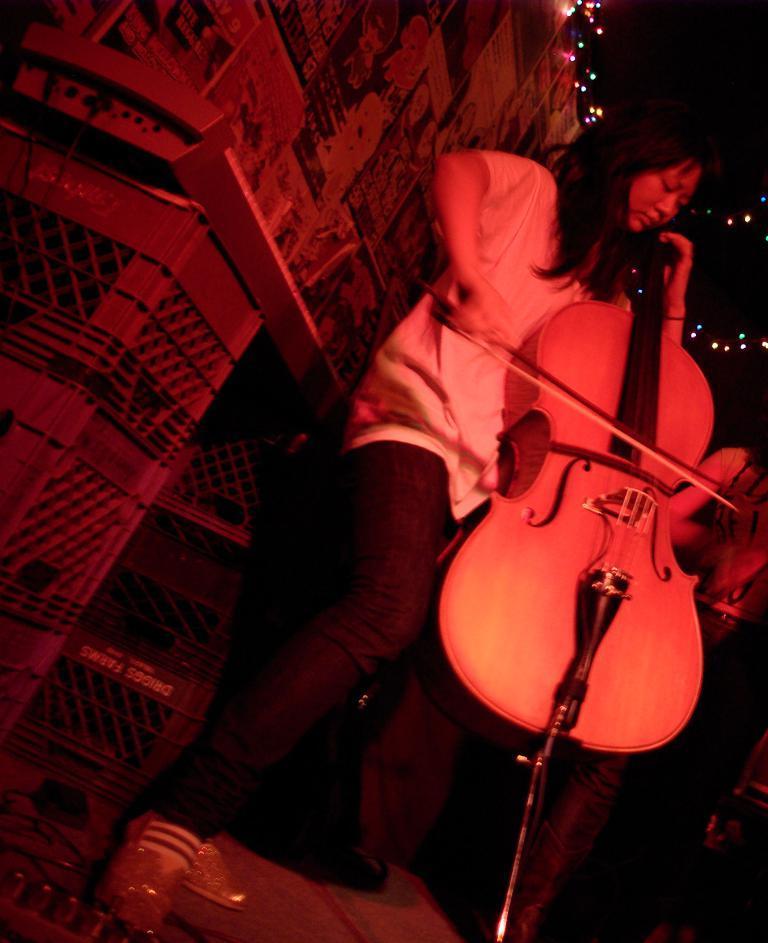Please provide a concise description of this image. In this image I can see a woman is playing a musical instrument. In the background I can see lights. 